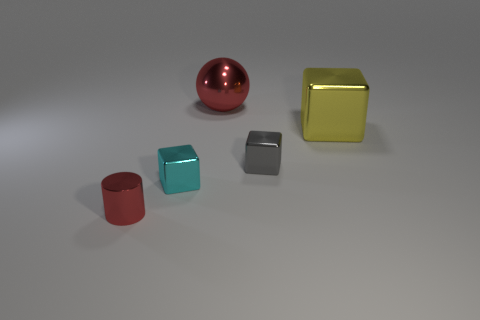Subtract all blue spheres. Subtract all red cubes. How many spheres are left? 1 Add 2 small things. How many objects exist? 7 Subtract all cubes. How many objects are left? 2 Add 5 yellow metallic blocks. How many yellow metallic blocks exist? 6 Subtract 0 blue balls. How many objects are left? 5 Subtract all gray metal cubes. Subtract all large gray spheres. How many objects are left? 4 Add 2 blocks. How many blocks are left? 5 